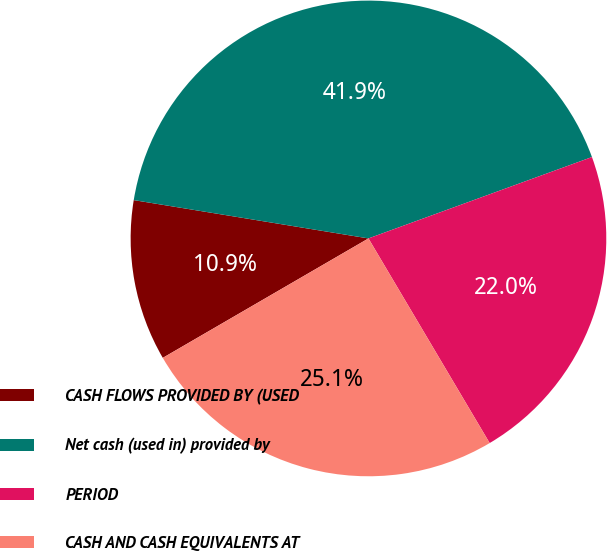<chart> <loc_0><loc_0><loc_500><loc_500><pie_chart><fcel>CASH FLOWS PROVIDED BY (USED<fcel>Net cash (used in) provided by<fcel>PERIOD<fcel>CASH AND CASH EQUIVALENTS AT<nl><fcel>10.95%<fcel>41.87%<fcel>22.05%<fcel>25.14%<nl></chart> 